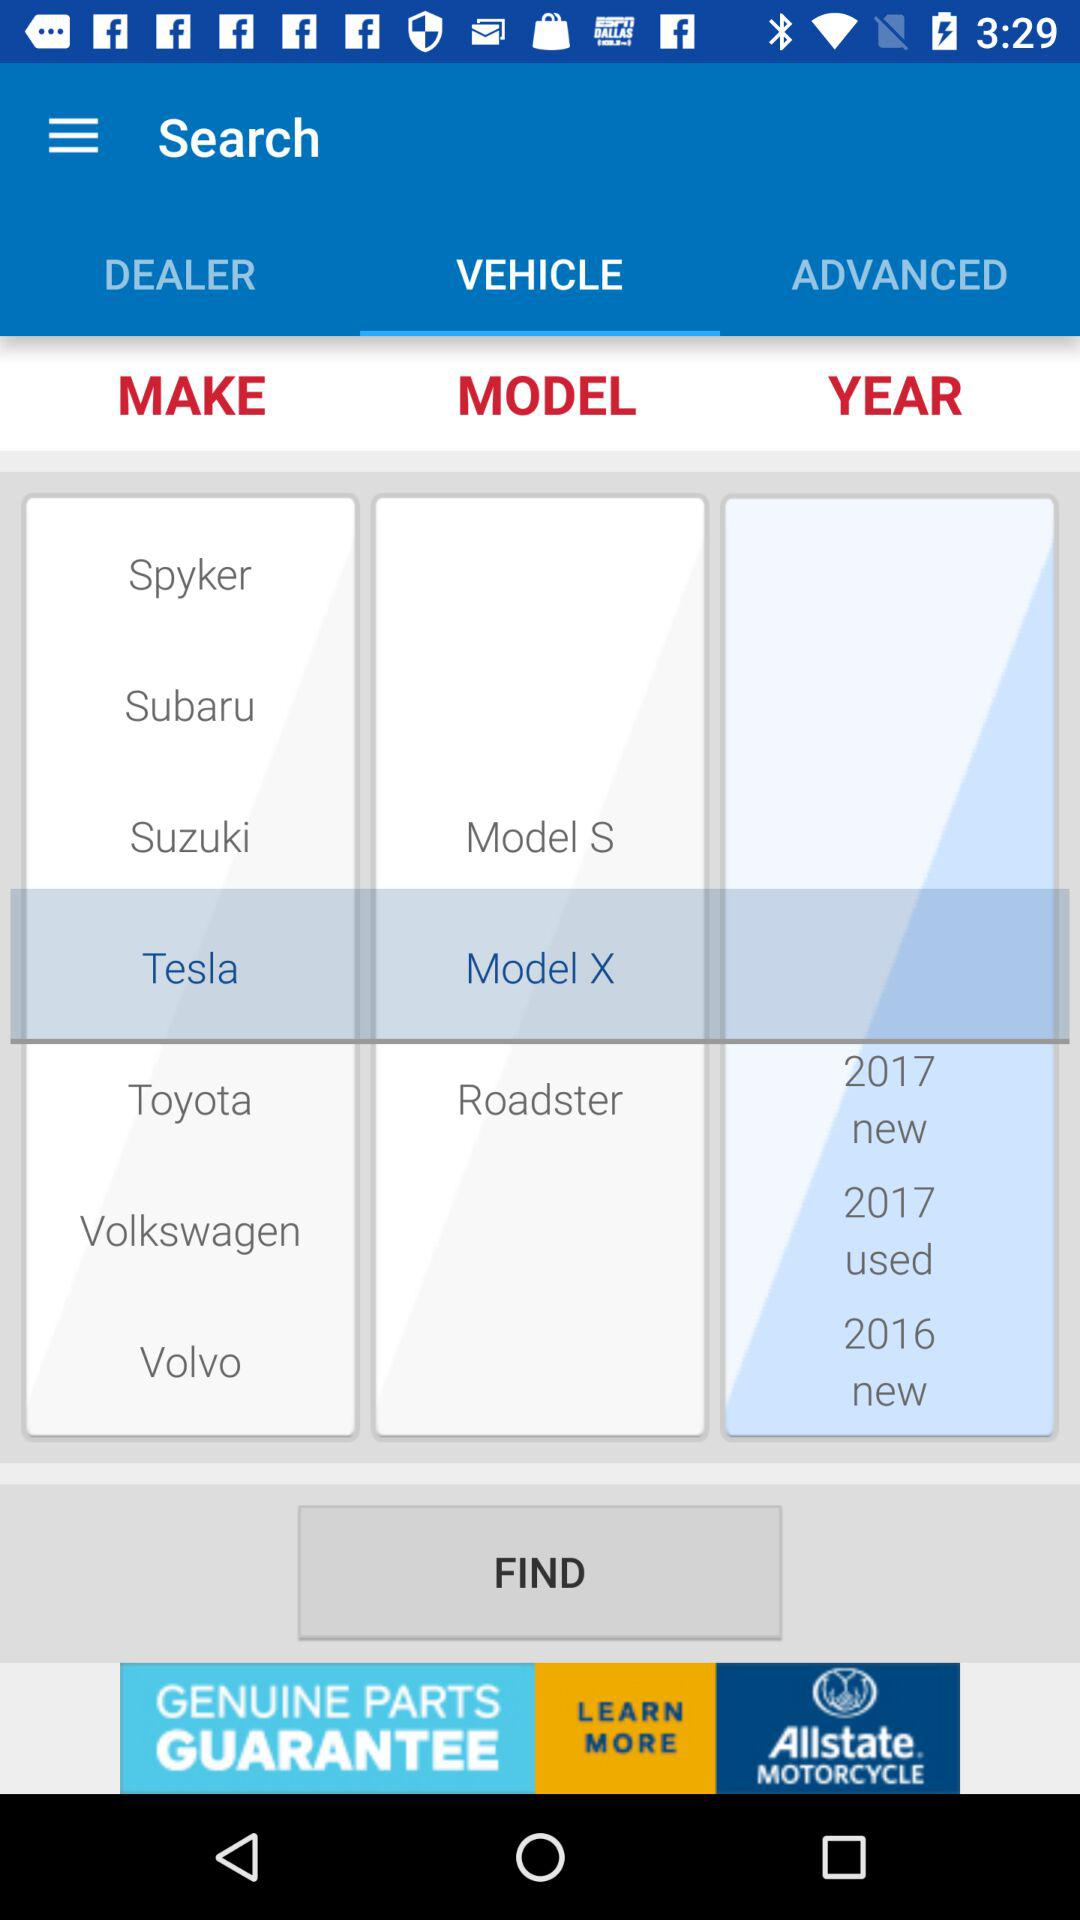Which model has been selected? The selected model is "Model X". 